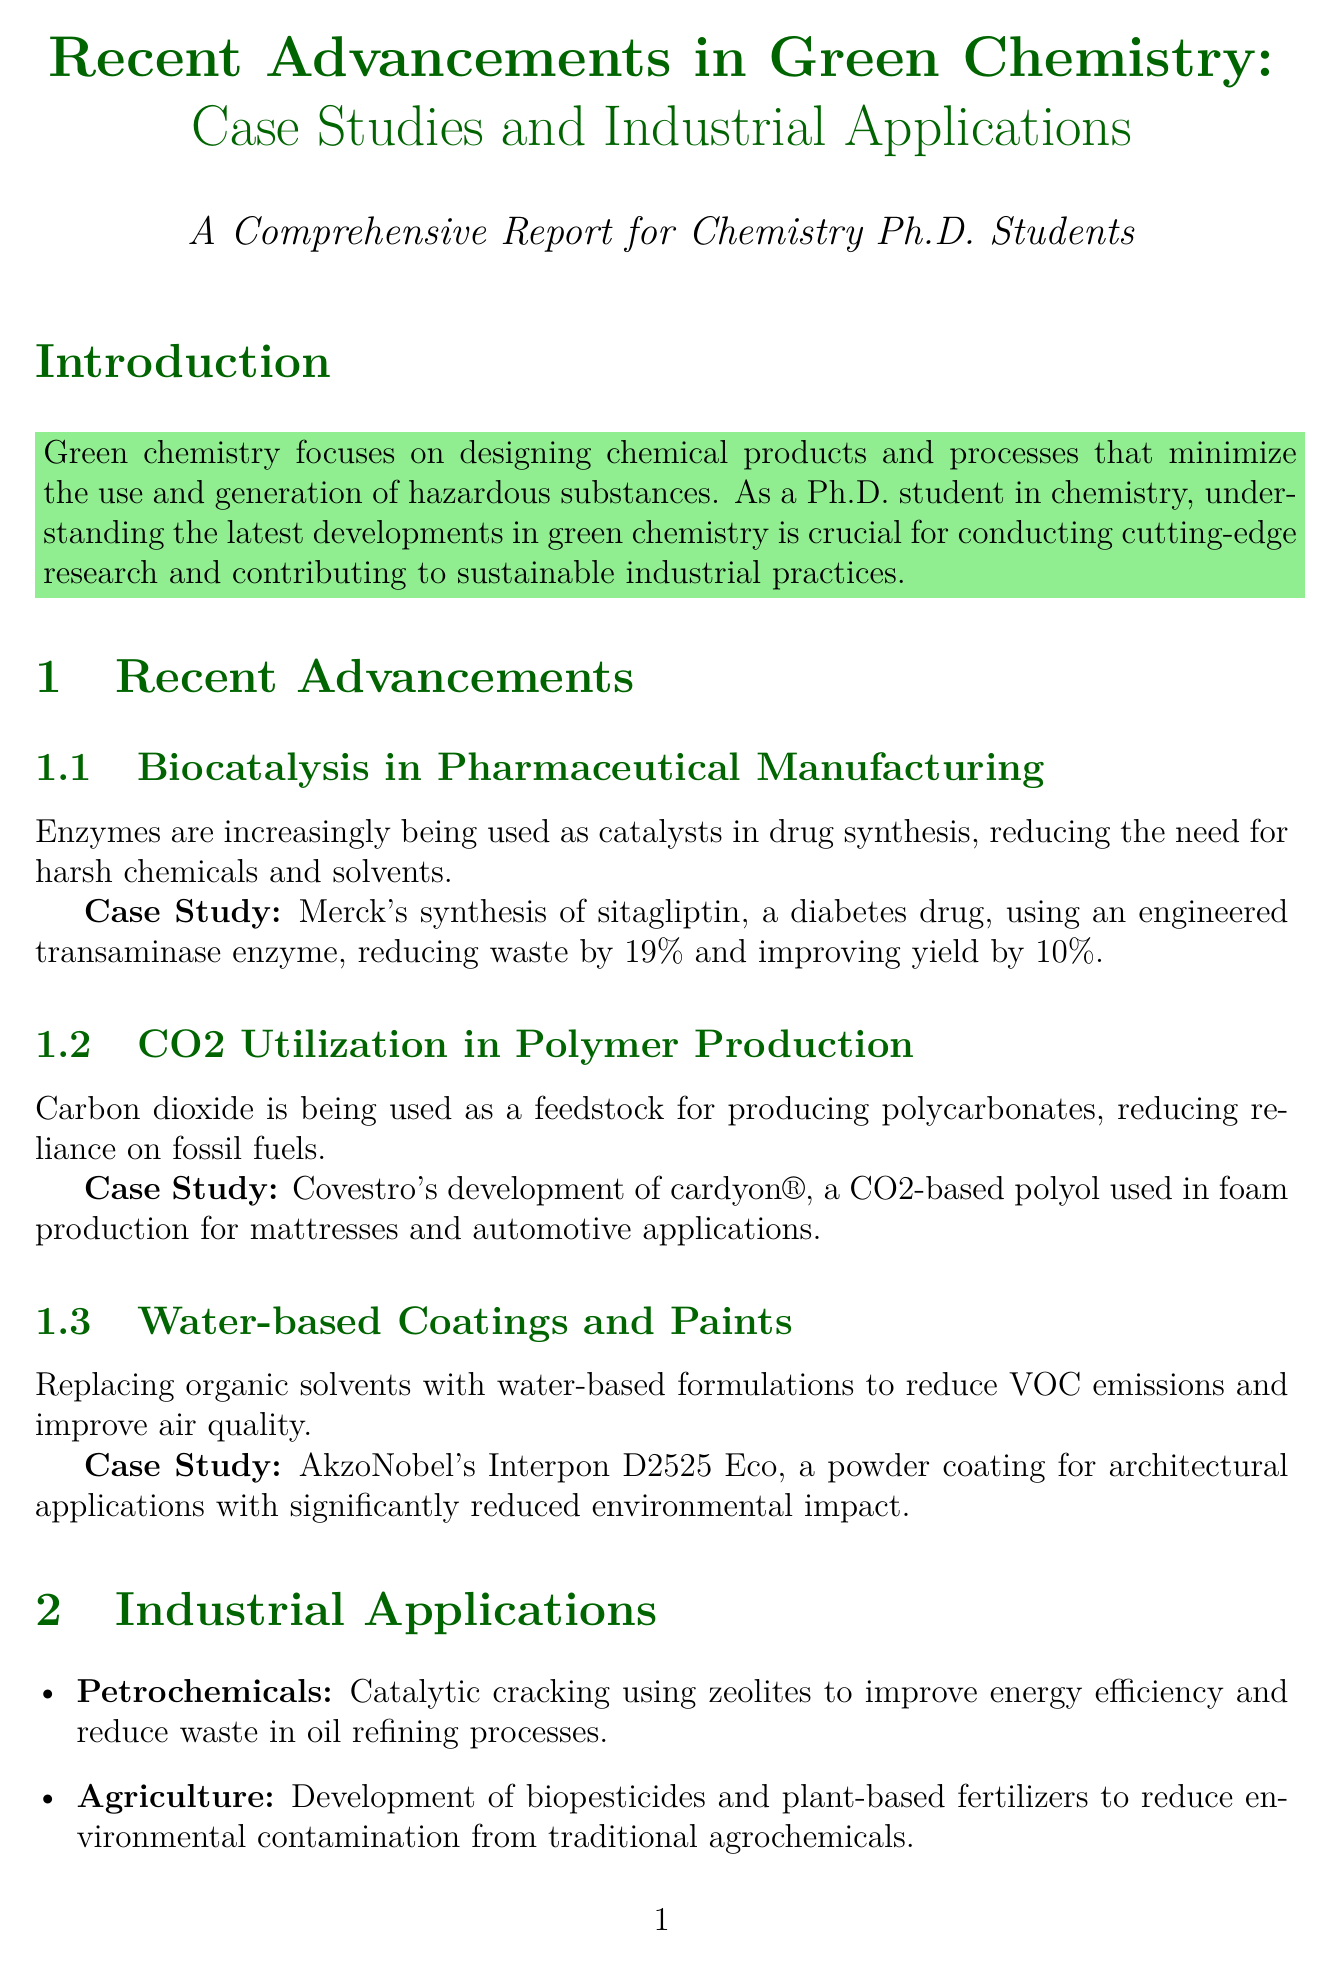What is the title of the report? The title of the report is explicitly stated at the beginning of the document.
Answer: Recent Advancements in Green Chemistry: Case Studies and Industrial Applications Who is affiliated with Yale University? The document lists key researchers and their affiliations.
Answer: Dr. Paul Anastas What is one advantage of biocatalysis in pharmaceutical manufacturing mentioned in the report? The report discusses the benefits of using enzymes in drug synthesis, including reducing the need for harmful chemicals.
Answer: Reducing the need for harsh chemicals and solvents What is the case study presented for CO2 utilization in polymer production? The document mentions specific case studies to illustrate recent advancements in green chemistry.
Answer: Covestro's development of cardyon® Which sector is associated with the development of biopesticides? The report outlines various industrial applications related to green chemistry advancements.
Answer: Agriculture What are two future directions mentioned for green chemistry? The document provides suggestions for further advancements in green chemistry, focusing on specific areas for development.
Answer: Artificial intelligence in molecular design, Expansion of bio-based feedstocks How many relevant journals are listed in the document? The document provides a list of journals related to green chemistry, which can be counted for the answer.
Answer: Three What is the main focus of green chemistry according to the introduction? The introduction defines the primary aim of green chemistry as outlined in the report.
Answer: Designing chemical products and processes that minimize the use and generation of hazardous substances 